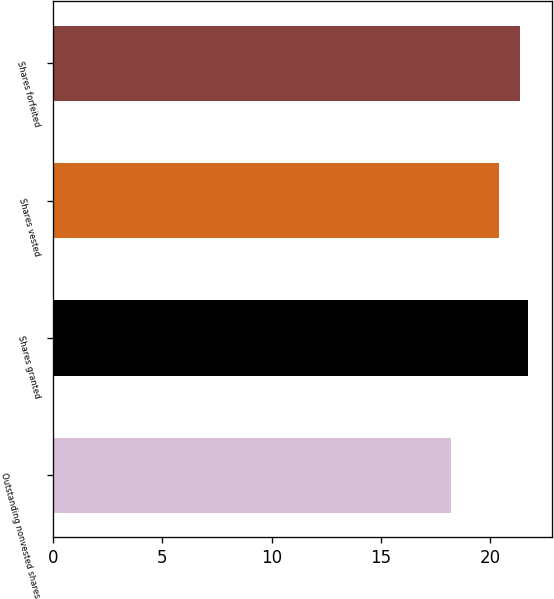Convert chart. <chart><loc_0><loc_0><loc_500><loc_500><bar_chart><fcel>Outstanding nonvested shares<fcel>Shares granted<fcel>Shares vested<fcel>Shares forfeited<nl><fcel>18.22<fcel>21.74<fcel>20.39<fcel>21.35<nl></chart> 